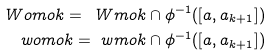Convert formula to latex. <formula><loc_0><loc_0><loc_500><loc_500>\ W o m o k = \ W m o k \cap \phi ^ { - 1 } ( [ a , a _ { k + 1 } ] ) \\ \ w o m o k = \ w m o k \cap \phi ^ { - 1 } ( [ a , a _ { k + 1 } ] )</formula> 